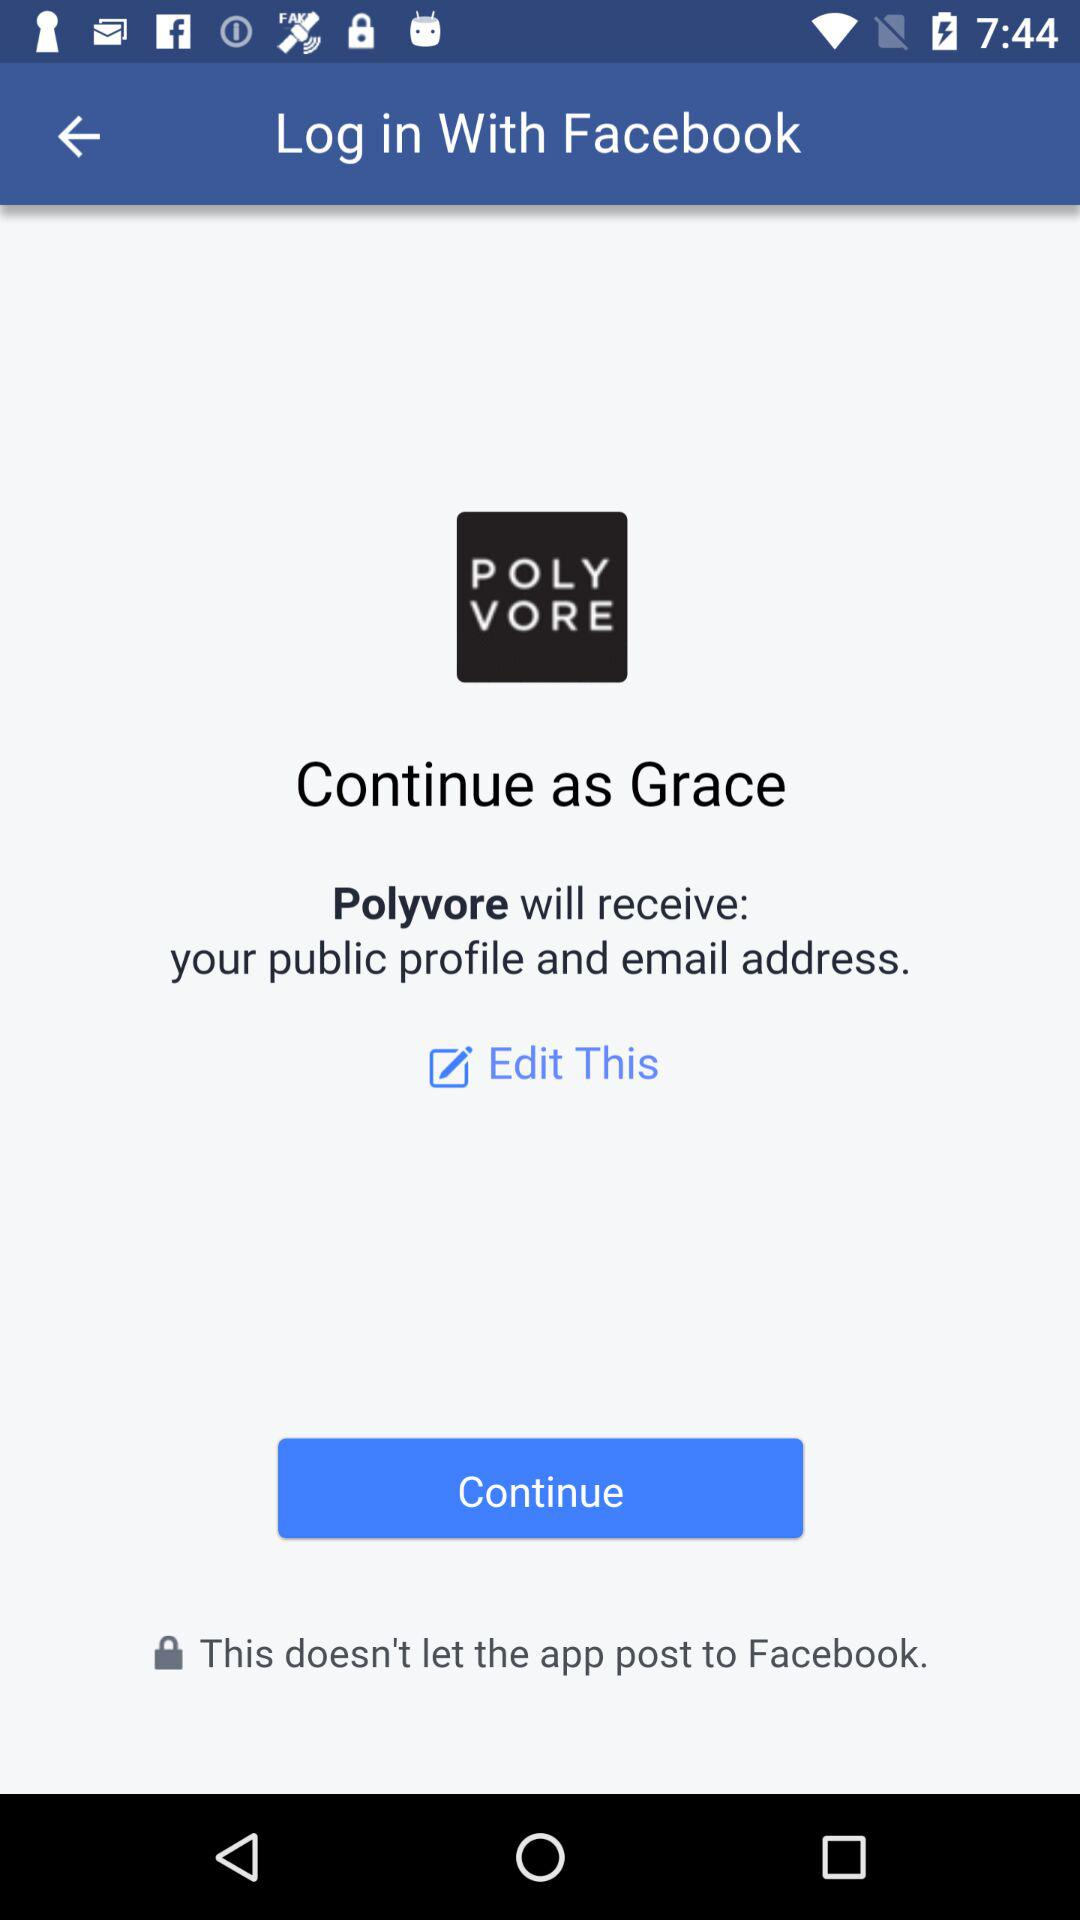What is the login name? The login name is Grace. 